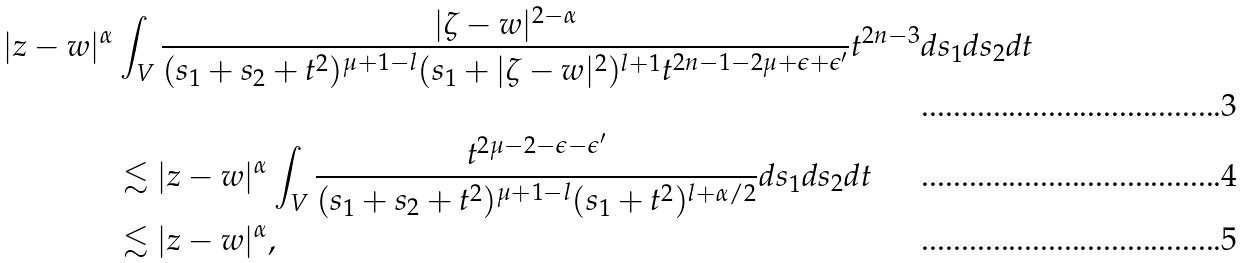Convert formula to latex. <formula><loc_0><loc_0><loc_500><loc_500>| z - w | ^ { \alpha } & \int _ { V } \frac { | \zeta - w | ^ { 2 - \alpha } } { ( s _ { 1 } + s _ { 2 } + t ^ { 2 } ) ^ { \mu + 1 - l } ( s _ { 1 } + | \zeta - w | ^ { 2 } ) ^ { l + 1 } t ^ { 2 n - 1 - 2 \mu + \epsilon + \epsilon ^ { \prime } } } t ^ { 2 n - 3 } d s _ { 1 } d s _ { 2 } d t \\ & \lesssim | z - w | ^ { \alpha } \int _ { V } \frac { t ^ { 2 \mu - 2 - \epsilon - \epsilon ^ { \prime } } } { ( s _ { 1 } + s _ { 2 } + t ^ { 2 } ) ^ { \mu + 1 - l } ( s _ { 1 } + t ^ { 2 } ) ^ { l + \alpha / 2 } } d s _ { 1 } d s _ { 2 } d t \\ & \lesssim | z - w | ^ { \alpha } ,</formula> 